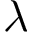<formula> <loc_0><loc_0><loc_500><loc_500>\lambda</formula> 